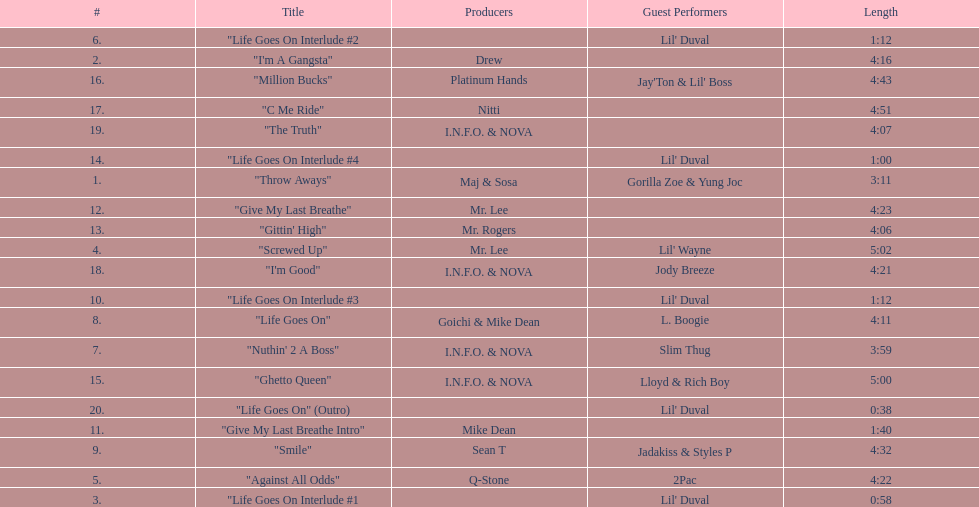How long is the longest track on the album? 5:02. Parse the full table. {'header': ['#', 'Title', 'Producers', 'Guest Performers', 'Length'], 'rows': [['6.', '"Life Goes On Interlude #2', '', "Lil' Duval", '1:12'], ['2.', '"I\'m A Gangsta"', 'Drew', '', '4:16'], ['16.', '"Million Bucks"', 'Platinum Hands', "Jay'Ton & Lil' Boss", '4:43'], ['17.', '"C Me Ride"', 'Nitti', '', '4:51'], ['19.', '"The Truth"', 'I.N.F.O. & NOVA', '', '4:07'], ['14.', '"Life Goes On Interlude #4', '', "Lil' Duval", '1:00'], ['1.', '"Throw Aways"', 'Maj & Sosa', 'Gorilla Zoe & Yung Joc', '3:11'], ['12.', '"Give My Last Breathe"', 'Mr. Lee', '', '4:23'], ['13.', '"Gittin\' High"', 'Mr. Rogers', '', '4:06'], ['4.', '"Screwed Up"', 'Mr. Lee', "Lil' Wayne", '5:02'], ['18.', '"I\'m Good"', 'I.N.F.O. & NOVA', 'Jody Breeze', '4:21'], ['10.', '"Life Goes On Interlude #3', '', "Lil' Duval", '1:12'], ['8.', '"Life Goes On"', 'Goichi & Mike Dean', 'L. Boogie', '4:11'], ['7.', '"Nuthin\' 2 A Boss"', 'I.N.F.O. & NOVA', 'Slim Thug', '3:59'], ['15.', '"Ghetto Queen"', 'I.N.F.O. & NOVA', 'Lloyd & Rich Boy', '5:00'], ['20.', '"Life Goes On" (Outro)', '', "Lil' Duval", '0:38'], ['11.', '"Give My Last Breathe Intro"', 'Mike Dean', '', '1:40'], ['9.', '"Smile"', 'Sean T', 'Jadakiss & Styles P', '4:32'], ['5.', '"Against All Odds"', 'Q-Stone', '2Pac', '4:22'], ['3.', '"Life Goes On Interlude #1', '', "Lil' Duval", '0:58']]} 